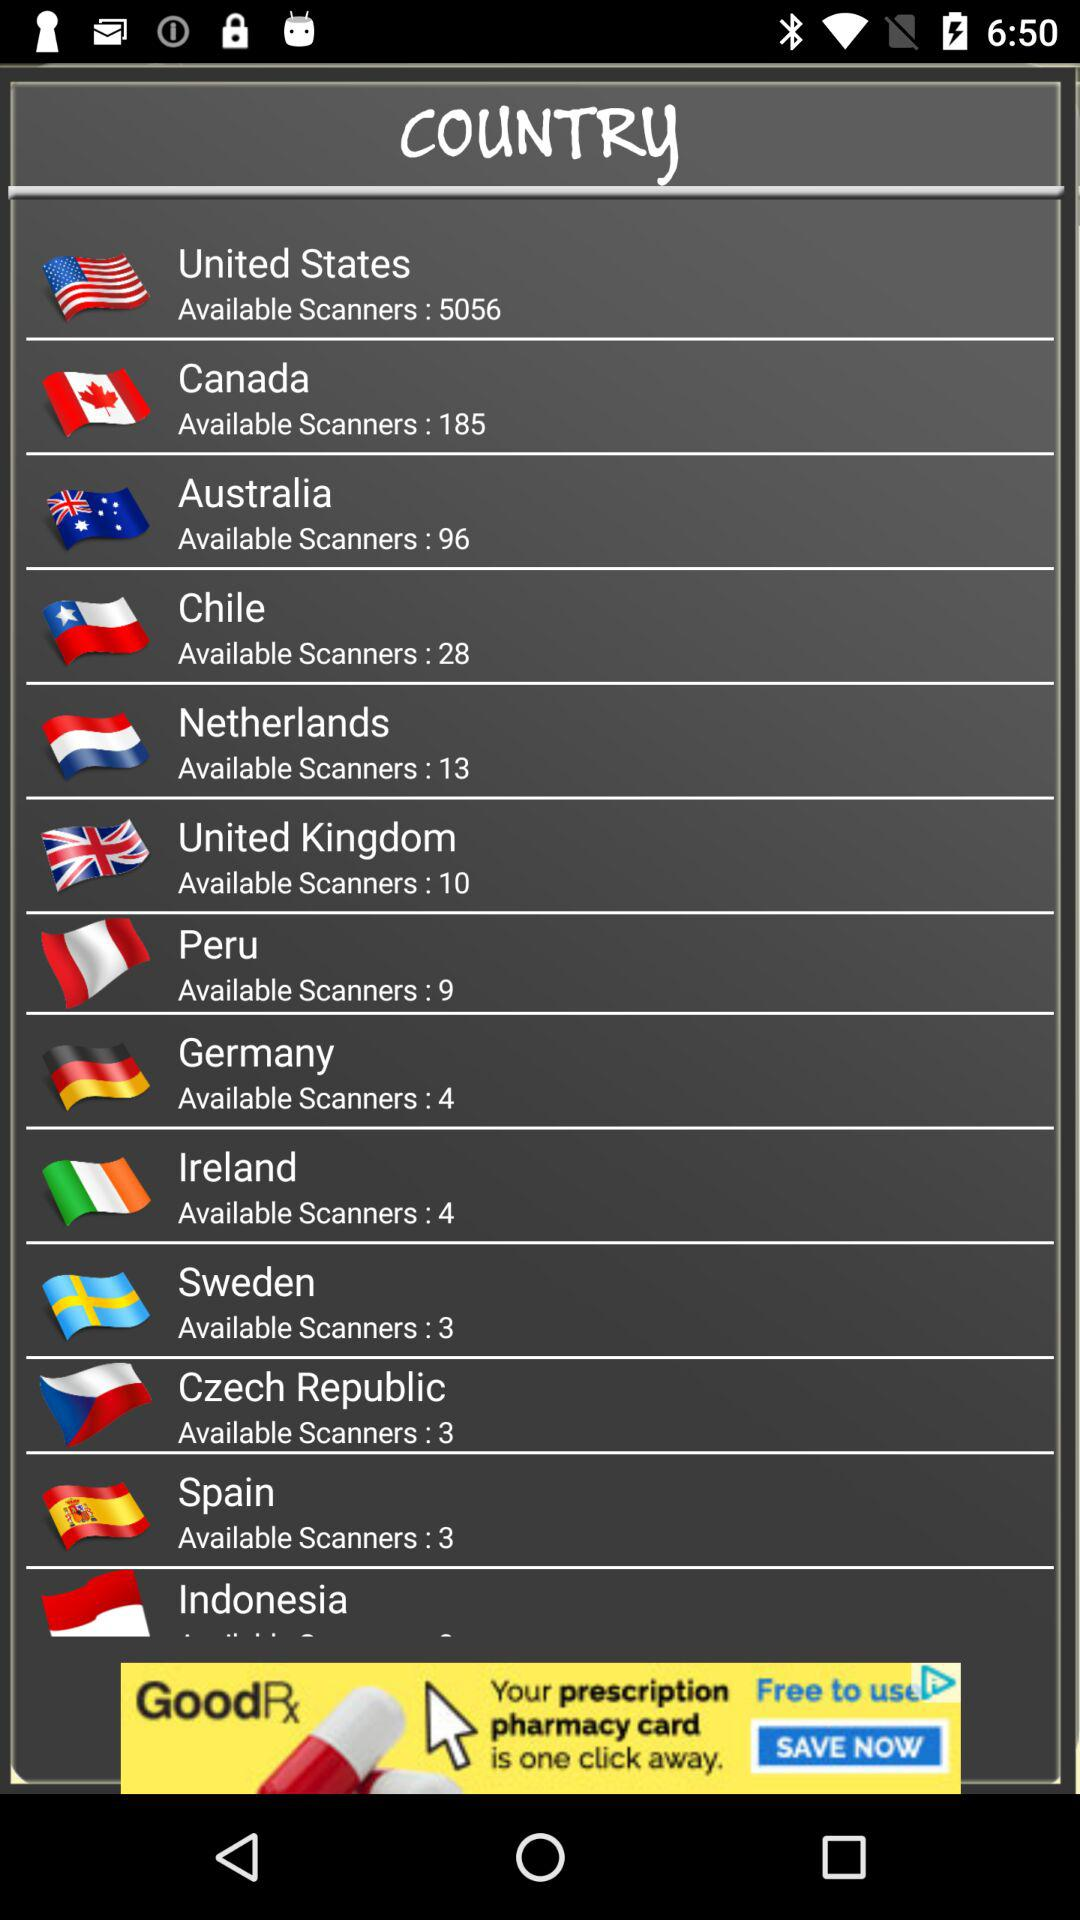How many scanners are available in Australia? There are 96 available scanners. 